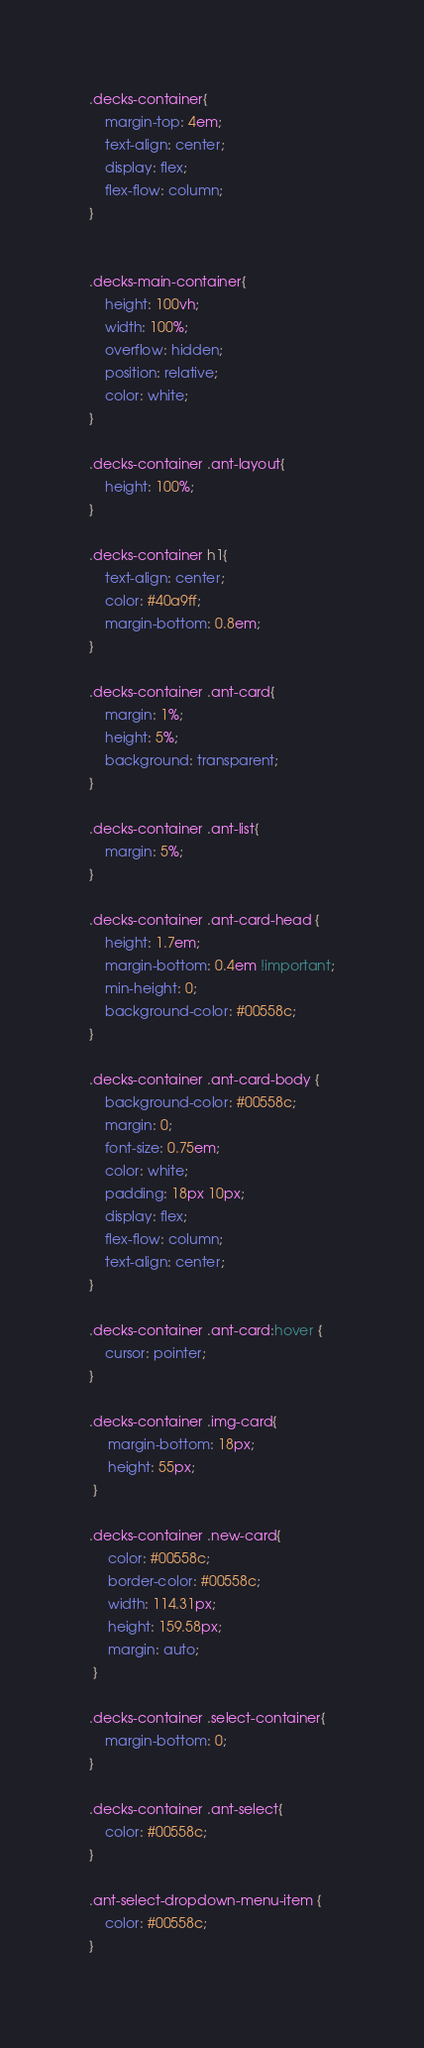<code> <loc_0><loc_0><loc_500><loc_500><_CSS_>.decks-container{
    margin-top: 4em;
    text-align: center;
    display: flex;
    flex-flow: column;
}


.decks-main-container{
    height: 100vh;
    width: 100%;
    overflow: hidden;
    position: relative;
    color: white;
}

.decks-container .ant-layout{
    height: 100%;
}

.decks-container h1{
    text-align: center;
    color: #40a9ff;
    margin-bottom: 0.8em;
}

.decks-container .ant-card{
    margin: 1%;
    height: 5%;
    background: transparent;
}

.decks-container .ant-list{
    margin: 5%;
}

.decks-container .ant-card-head {
    height: 1.7em;
    margin-bottom: 0.4em !important;
    min-height: 0;
    background-color: #00558c;
}

.decks-container .ant-card-body {
    background-color: #00558c;
    margin: 0;
    font-size: 0.75em;
    color: white;
    padding: 18px 10px;
    display: flex;
    flex-flow: column;
    text-align: center;
}

.decks-container .ant-card:hover {
    cursor: pointer;
}

.decks-container .img-card{
     margin-bottom: 18px;
     height: 55px;
 }

.decks-container .new-card{
     color: #00558c;
     border-color: #00558c;
     width: 114.31px;
     height: 159.58px;
     margin: auto;
 }

.decks-container .select-container{
    margin-bottom: 0;
}

.decks-container .ant-select{
    color: #00558c;
}

.ant-select-dropdown-menu-item {
    color: #00558c;
}</code> 